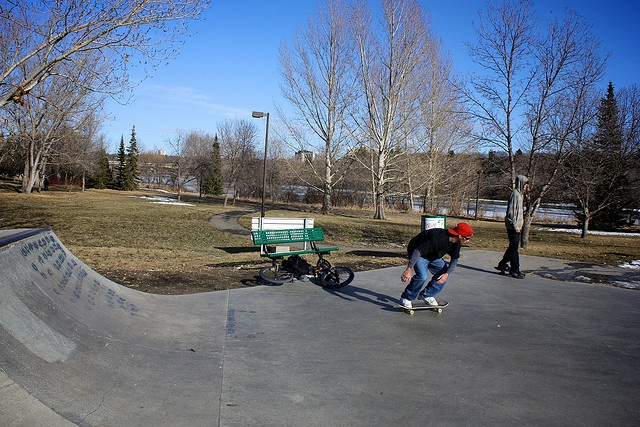Describe the objects in this image and their specific colors. I can see people in blue, black, navy, and gray tones, bench in blue, teal, black, darkgray, and gray tones, people in blue, black, darkgray, and gray tones, bicycle in blue, black, gray, and navy tones, and backpack in blue, black, and gray tones in this image. 